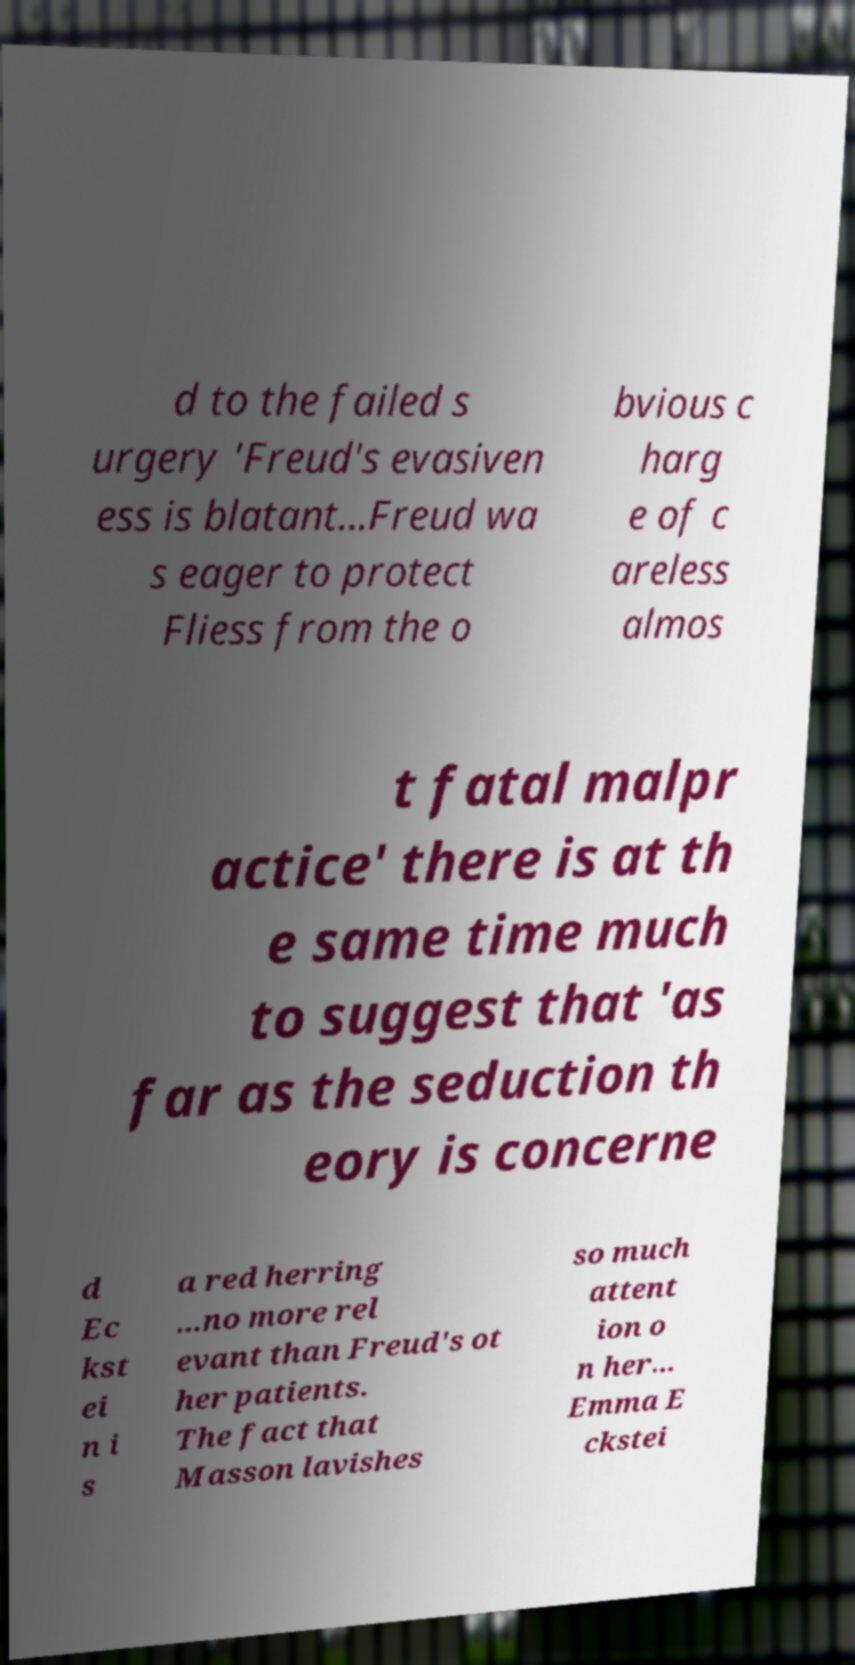Could you extract and type out the text from this image? d to the failed s urgery 'Freud's evasiven ess is blatant...Freud wa s eager to protect Fliess from the o bvious c harg e of c areless almos t fatal malpr actice' there is at th e same time much to suggest that 'as far as the seduction th eory is concerne d Ec kst ei n i s a red herring ...no more rel evant than Freud's ot her patients. The fact that Masson lavishes so much attent ion o n her... Emma E ckstei 